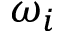<formula> <loc_0><loc_0><loc_500><loc_500>\omega _ { i }</formula> 